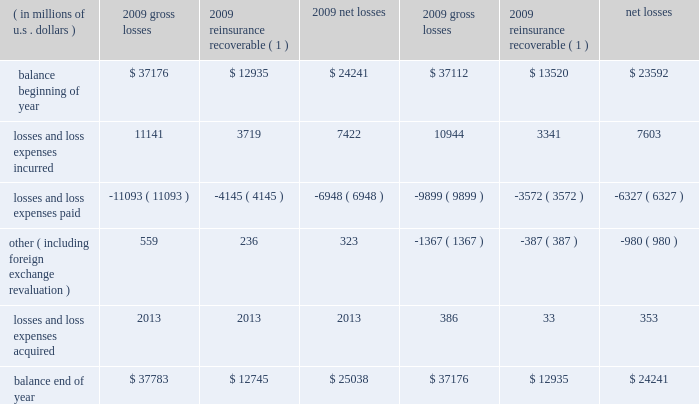Critical accounting estimates our consolidated financial statements include amounts that , either by their nature or due to requirements of accounting princi- ples generally accepted in the u.s .
( gaap ) , are determined using best estimates and assumptions .
While we believe that the amounts included in our consolidated financial statements reflect our best judgment , actual amounts could ultimately materi- ally differ from those currently presented .
We believe the items that require the most subjective and complex estimates are : 2022 unpaid loss and loss expense reserves , including long-tail asbestos and environmental ( a&e ) reserves ; 2022 future policy benefits reserves ; 2022 valuation of value of business acquired ( voba ) and amortization of deferred policy acquisition costs and voba ; 2022 the assessment of risk transfer for certain structured insurance and reinsurance contracts ; 2022 reinsurance recoverable , including a provision for uncollectible reinsurance ; 2022 the valuation of our investment portfolio and assessment of other-than-temporary impairments ( otti ) ; 2022 the valuation of deferred tax assets ; 2022 the valuation of derivative instruments related to guaranteed minimum income benefits ( gmib ) ; and 2022 the valuation of goodwill .
We believe our accounting policies for these items are of critical importance to our consolidated financial statements .
The following discussion provides more information regarding the estimates and assumptions required to arrive at these amounts and should be read in conjunction with the sections entitled : prior period development , asbestos and environmental and other run-off liabilities , reinsurance recoverable on ceded reinsurance , investments , net realized gains ( losses ) , and other income and expense items .
Unpaid losses and loss expenses overview and key data as an insurance and reinsurance company , we are required , by applicable laws and regulations and gaap , to establish loss and loss expense reserves for the estimated unpaid portion of the ultimate liability for losses and loss expenses under the terms of our policies and agreements with our insured and reinsured customers .
The estimate of the liabilities includes provisions for claims that have been reported but are unpaid at the balance sheet date ( case reserves ) and for future obligations on claims that have been incurred but not reported ( ibnr ) at the balance sheet date ( ibnr may also include a provision for additional development on reported claims in instances where the case reserve is viewed to be potentially insufficient ) .
Loss reserves also include an estimate of expenses associated with processing and settling unpaid claims ( loss expenses ) .
At december 31 , 2009 , our gross unpaid loss and loss expense reserves were $ 37.8 billion and our net unpaid loss and loss expense reserves were $ 25 billion .
With the exception of certain structured settlements , for which the timing and amount of future claim pay- ments are reliably determinable , our loss reserves are not discounted for the time value of money .
In connection with such structured settlements , we carry net reserves of $ 76 million , net of discount .
The table below presents a roll-forward of our unpaid losses and loss expenses for the years ended december 31 , 2009 and 2008. .
( 1 ) net of provision for uncollectible reinsurance .
What is the percentage change in net unpaid losses from 2008 to 2009? 
Computations: ((25038 - 24241) / 24241)
Answer: 0.03288. 